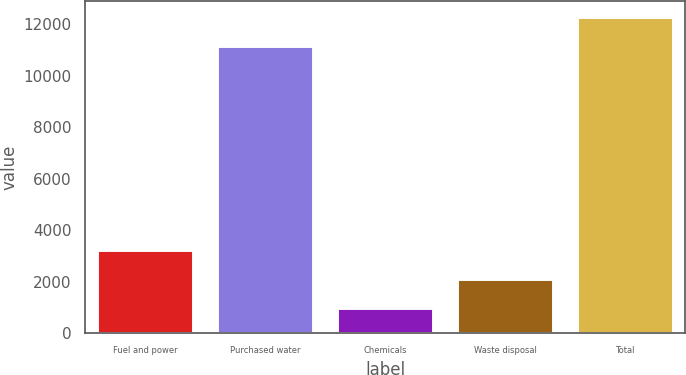Convert chart to OTSL. <chart><loc_0><loc_0><loc_500><loc_500><bar_chart><fcel>Fuel and power<fcel>Purchased water<fcel>Chemicals<fcel>Waste disposal<fcel>Total<nl><fcel>3226.4<fcel>11165<fcel>980<fcel>2103.2<fcel>12288.2<nl></chart> 